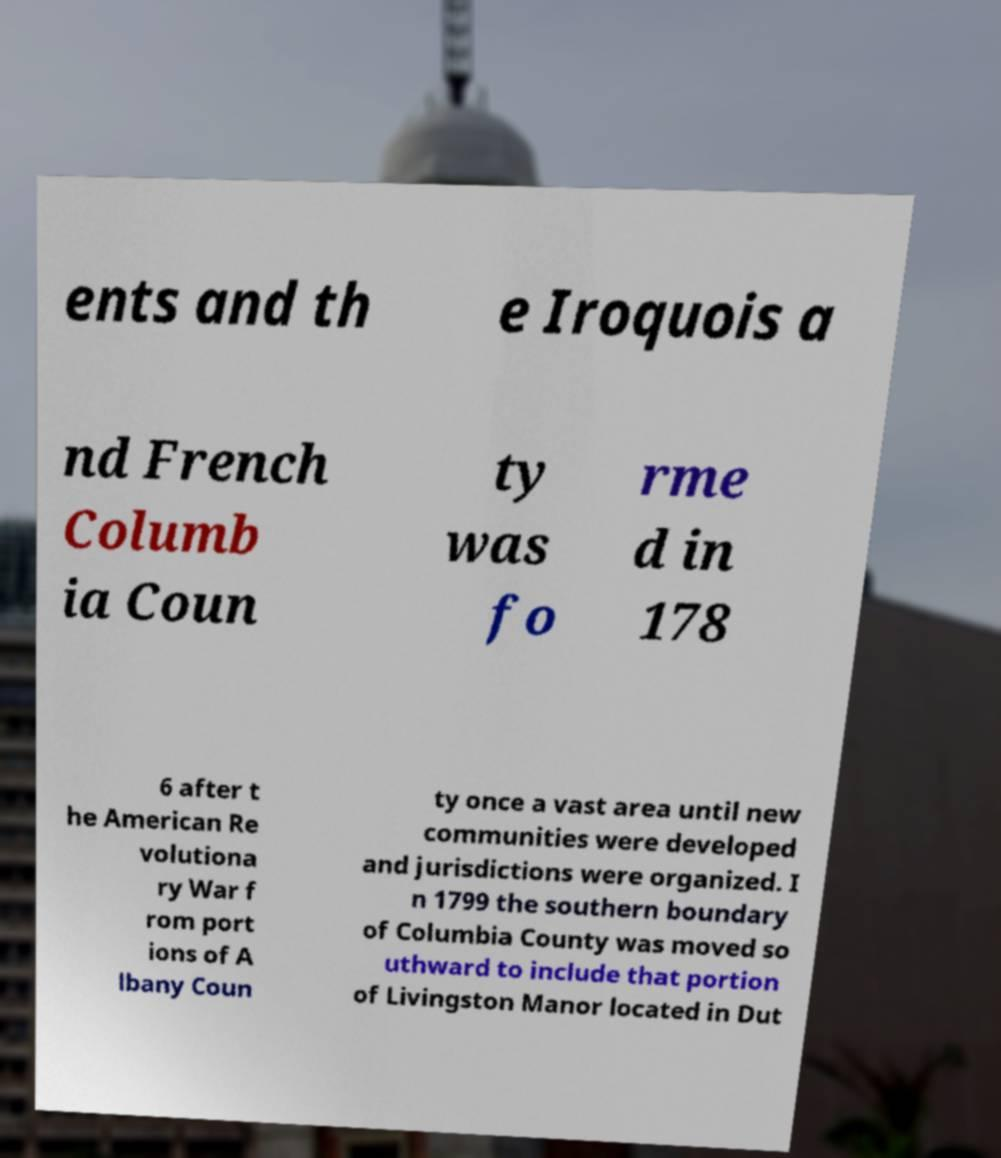I need the written content from this picture converted into text. Can you do that? ents and th e Iroquois a nd French Columb ia Coun ty was fo rme d in 178 6 after t he American Re volutiona ry War f rom port ions of A lbany Coun ty once a vast area until new communities were developed and jurisdictions were organized. I n 1799 the southern boundary of Columbia County was moved so uthward to include that portion of Livingston Manor located in Dut 